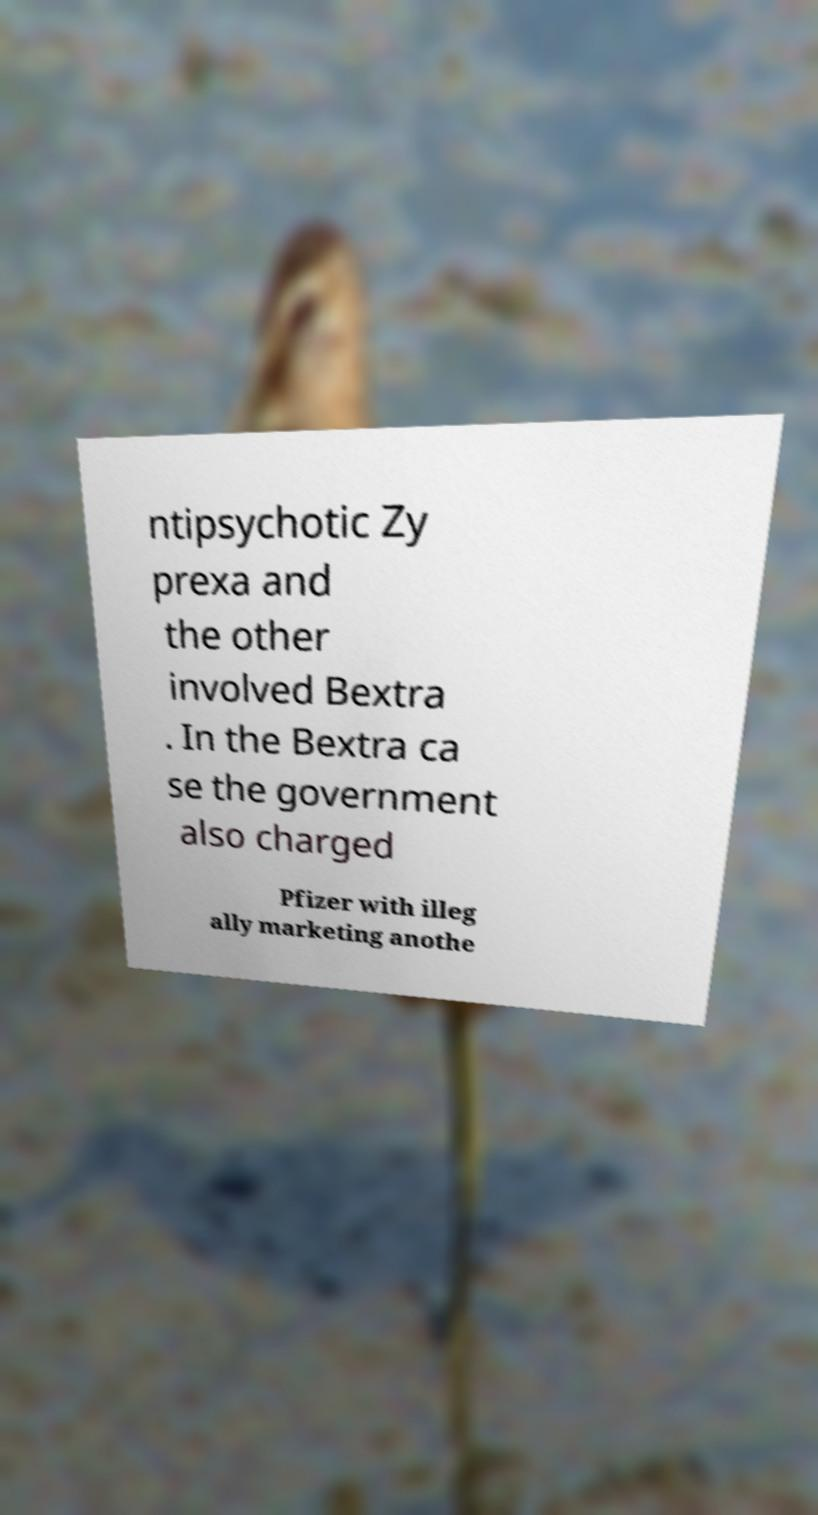Can you read and provide the text displayed in the image?This photo seems to have some interesting text. Can you extract and type it out for me? ntipsychotic Zy prexa and the other involved Bextra . In the Bextra ca se the government also charged Pfizer with illeg ally marketing anothe 